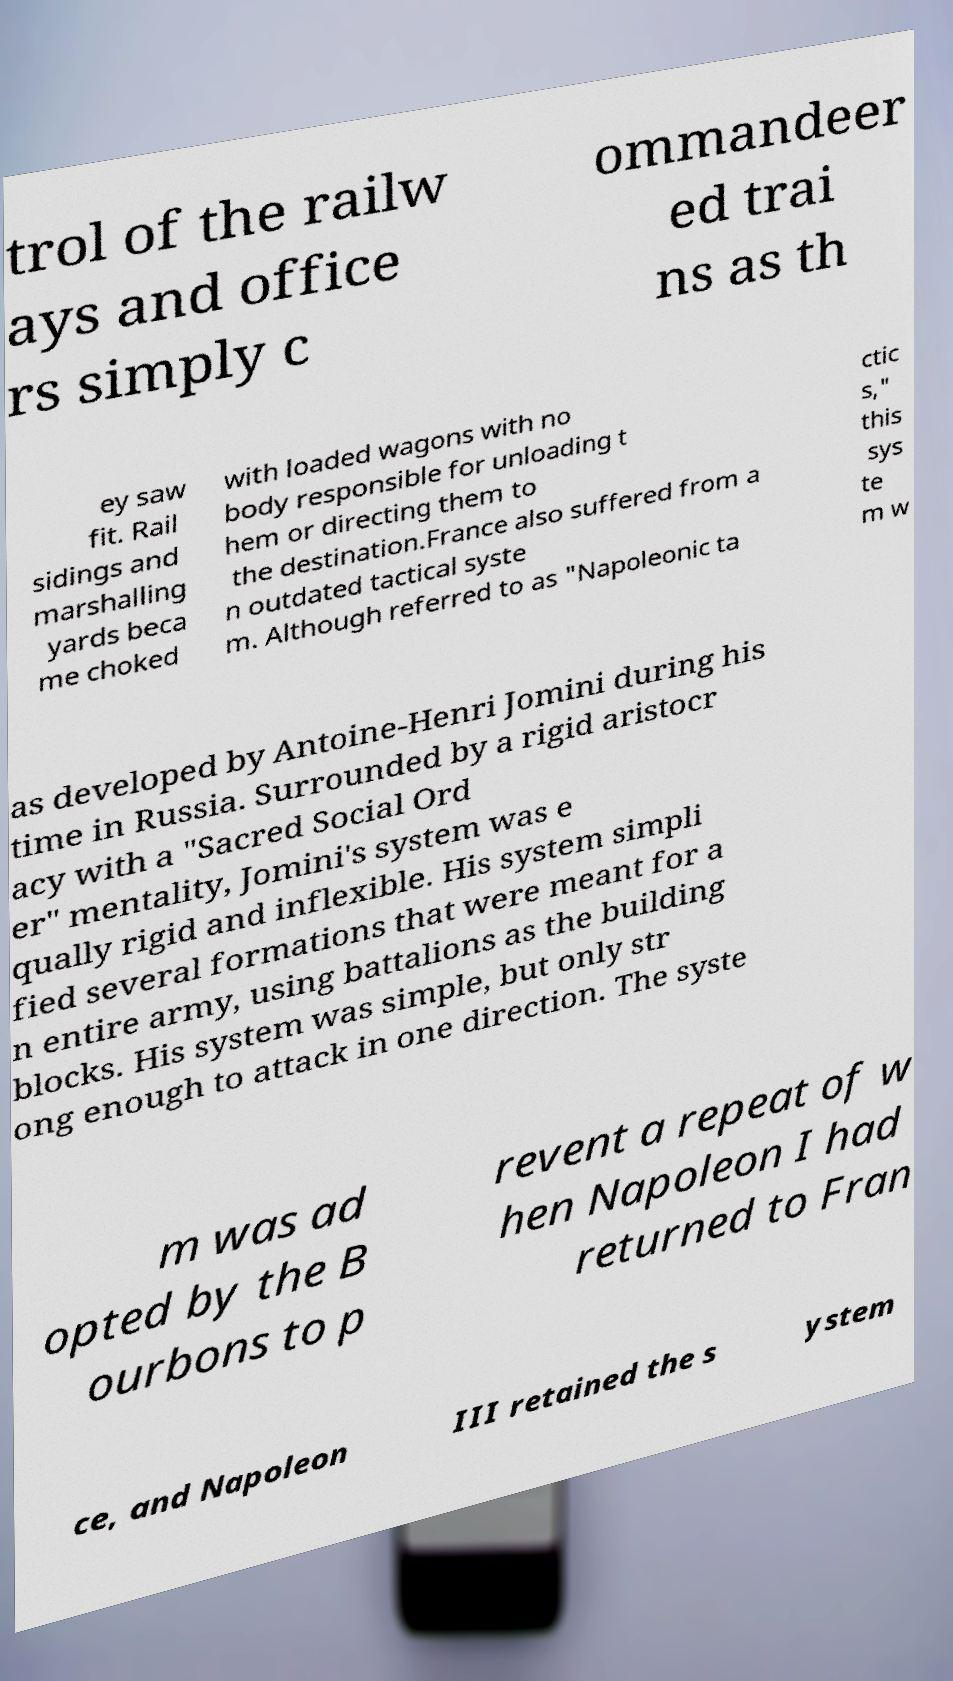Please identify and transcribe the text found in this image. trol of the railw ays and office rs simply c ommandeer ed trai ns as th ey saw fit. Rail sidings and marshalling yards beca me choked with loaded wagons with no body responsible for unloading t hem or directing them to the destination.France also suffered from a n outdated tactical syste m. Although referred to as "Napoleonic ta ctic s," this sys te m w as developed by Antoine-Henri Jomini during his time in Russia. Surrounded by a rigid aristocr acy with a "Sacred Social Ord er" mentality, Jomini's system was e qually rigid and inflexible. His system simpli fied several formations that were meant for a n entire army, using battalions as the building blocks. His system was simple, but only str ong enough to attack in one direction. The syste m was ad opted by the B ourbons to p revent a repeat of w hen Napoleon I had returned to Fran ce, and Napoleon III retained the s ystem 